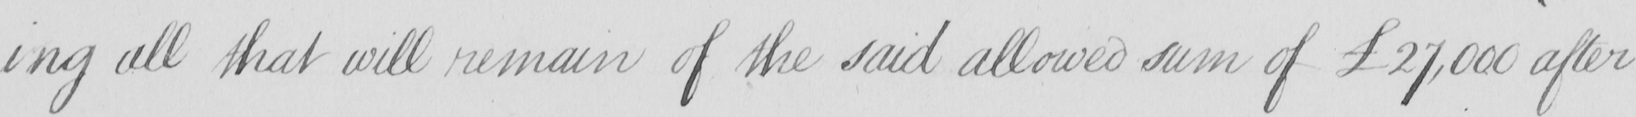Can you tell me what this handwritten text says? -ing all that will remain of the said allowed sum of £27,000 after 